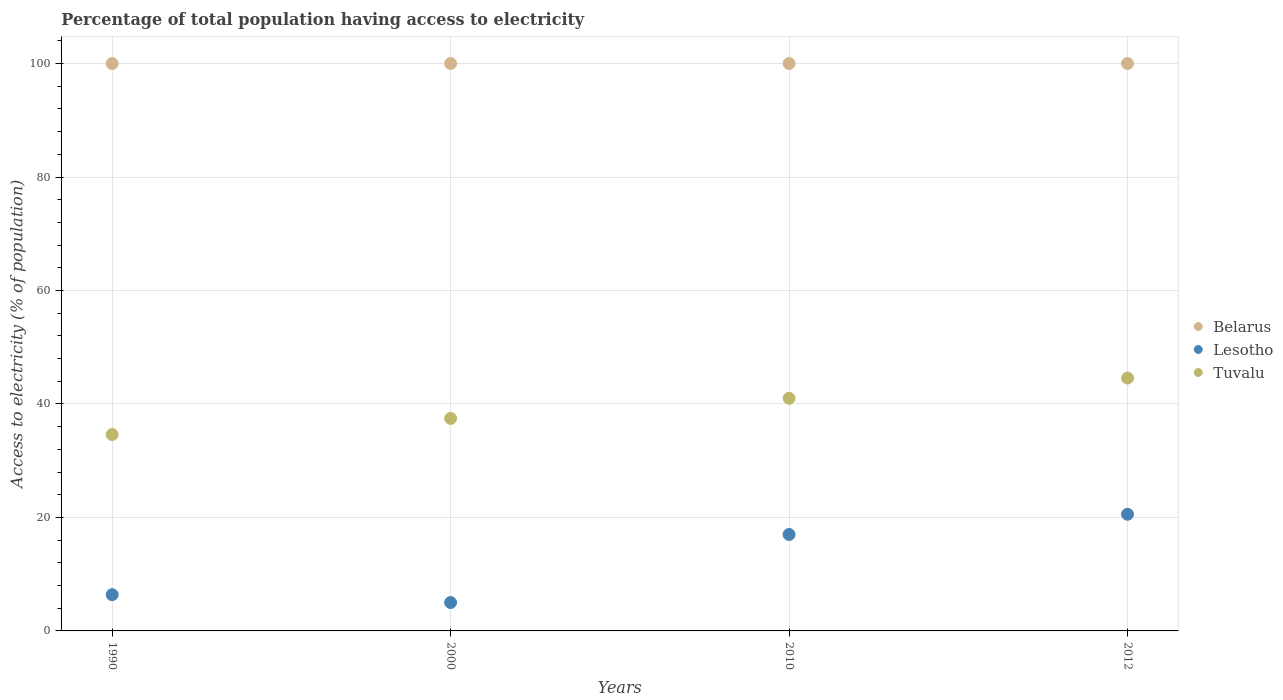What is the percentage of population that have access to electricity in Belarus in 2010?
Give a very brief answer. 100. Across all years, what is the maximum percentage of population that have access to electricity in Lesotho?
Provide a short and direct response. 20.56. Across all years, what is the minimum percentage of population that have access to electricity in Lesotho?
Provide a short and direct response. 5. In which year was the percentage of population that have access to electricity in Belarus minimum?
Provide a succinct answer. 1990. What is the total percentage of population that have access to electricity in Lesotho in the graph?
Your answer should be compact. 48.95. What is the difference between the percentage of population that have access to electricity in Lesotho in 1990 and that in 2010?
Provide a succinct answer. -10.61. What is the difference between the percentage of population that have access to electricity in Tuvalu in 1990 and the percentage of population that have access to electricity in Belarus in 2012?
Offer a very short reply. -65.38. What is the average percentage of population that have access to electricity in Tuvalu per year?
Keep it short and to the point. 39.41. In the year 2010, what is the difference between the percentage of population that have access to electricity in Lesotho and percentage of population that have access to electricity in Tuvalu?
Your response must be concise. -24. What is the ratio of the percentage of population that have access to electricity in Tuvalu in 2000 to that in 2012?
Your answer should be compact. 0.84. Is the difference between the percentage of population that have access to electricity in Lesotho in 1990 and 2012 greater than the difference between the percentage of population that have access to electricity in Tuvalu in 1990 and 2012?
Keep it short and to the point. No. What is the difference between the highest and the second highest percentage of population that have access to electricity in Lesotho?
Your answer should be compact. 3.56. What is the difference between the highest and the lowest percentage of population that have access to electricity in Tuvalu?
Make the answer very short. 9.95. Does the percentage of population that have access to electricity in Lesotho monotonically increase over the years?
Your answer should be very brief. No. Is the percentage of population that have access to electricity in Tuvalu strictly greater than the percentage of population that have access to electricity in Belarus over the years?
Ensure brevity in your answer.  No. Is the percentage of population that have access to electricity in Belarus strictly less than the percentage of population that have access to electricity in Tuvalu over the years?
Offer a terse response. No. How many dotlines are there?
Make the answer very short. 3. How many years are there in the graph?
Your answer should be very brief. 4. Are the values on the major ticks of Y-axis written in scientific E-notation?
Provide a short and direct response. No. Where does the legend appear in the graph?
Provide a short and direct response. Center right. How are the legend labels stacked?
Offer a terse response. Vertical. What is the title of the graph?
Provide a succinct answer. Percentage of total population having access to electricity. What is the label or title of the Y-axis?
Your answer should be very brief. Access to electricity (% of population). What is the Access to electricity (% of population) in Lesotho in 1990?
Ensure brevity in your answer.  6.39. What is the Access to electricity (% of population) of Tuvalu in 1990?
Offer a very short reply. 34.62. What is the Access to electricity (% of population) in Lesotho in 2000?
Give a very brief answer. 5. What is the Access to electricity (% of population) in Tuvalu in 2000?
Your answer should be compact. 37.46. What is the Access to electricity (% of population) of Belarus in 2010?
Ensure brevity in your answer.  100. What is the Access to electricity (% of population) of Lesotho in 2010?
Make the answer very short. 17. What is the Access to electricity (% of population) of Tuvalu in 2010?
Provide a short and direct response. 41. What is the Access to electricity (% of population) of Belarus in 2012?
Offer a terse response. 100. What is the Access to electricity (% of population) in Lesotho in 2012?
Give a very brief answer. 20.56. What is the Access to electricity (% of population) of Tuvalu in 2012?
Your response must be concise. 44.56. Across all years, what is the maximum Access to electricity (% of population) in Belarus?
Provide a short and direct response. 100. Across all years, what is the maximum Access to electricity (% of population) of Lesotho?
Ensure brevity in your answer.  20.56. Across all years, what is the maximum Access to electricity (% of population) of Tuvalu?
Your answer should be very brief. 44.56. Across all years, what is the minimum Access to electricity (% of population) in Belarus?
Provide a succinct answer. 100. Across all years, what is the minimum Access to electricity (% of population) of Lesotho?
Offer a terse response. 5. Across all years, what is the minimum Access to electricity (% of population) of Tuvalu?
Make the answer very short. 34.62. What is the total Access to electricity (% of population) in Belarus in the graph?
Your answer should be very brief. 400. What is the total Access to electricity (% of population) of Lesotho in the graph?
Offer a terse response. 48.95. What is the total Access to electricity (% of population) of Tuvalu in the graph?
Your answer should be compact. 157.63. What is the difference between the Access to electricity (% of population) of Belarus in 1990 and that in 2000?
Offer a terse response. 0. What is the difference between the Access to electricity (% of population) in Lesotho in 1990 and that in 2000?
Give a very brief answer. 1.39. What is the difference between the Access to electricity (% of population) of Tuvalu in 1990 and that in 2000?
Your answer should be compact. -2.84. What is the difference between the Access to electricity (% of population) in Lesotho in 1990 and that in 2010?
Provide a succinct answer. -10.61. What is the difference between the Access to electricity (% of population) in Tuvalu in 1990 and that in 2010?
Make the answer very short. -6.38. What is the difference between the Access to electricity (% of population) of Lesotho in 1990 and that in 2012?
Offer a very short reply. -14.17. What is the difference between the Access to electricity (% of population) of Tuvalu in 1990 and that in 2012?
Offer a terse response. -9.95. What is the difference between the Access to electricity (% of population) in Lesotho in 2000 and that in 2010?
Your answer should be compact. -12. What is the difference between the Access to electricity (% of population) in Tuvalu in 2000 and that in 2010?
Your answer should be compact. -3.54. What is the difference between the Access to electricity (% of population) in Lesotho in 2000 and that in 2012?
Offer a very short reply. -15.56. What is the difference between the Access to electricity (% of population) of Tuvalu in 2000 and that in 2012?
Give a very brief answer. -7.11. What is the difference between the Access to electricity (% of population) in Lesotho in 2010 and that in 2012?
Your answer should be very brief. -3.56. What is the difference between the Access to electricity (% of population) in Tuvalu in 2010 and that in 2012?
Provide a short and direct response. -3.56. What is the difference between the Access to electricity (% of population) in Belarus in 1990 and the Access to electricity (% of population) in Lesotho in 2000?
Your answer should be very brief. 95. What is the difference between the Access to electricity (% of population) in Belarus in 1990 and the Access to electricity (% of population) in Tuvalu in 2000?
Make the answer very short. 62.54. What is the difference between the Access to electricity (% of population) in Lesotho in 1990 and the Access to electricity (% of population) in Tuvalu in 2000?
Keep it short and to the point. -31.07. What is the difference between the Access to electricity (% of population) in Lesotho in 1990 and the Access to electricity (% of population) in Tuvalu in 2010?
Provide a succinct answer. -34.61. What is the difference between the Access to electricity (% of population) of Belarus in 1990 and the Access to electricity (% of population) of Lesotho in 2012?
Your answer should be compact. 79.44. What is the difference between the Access to electricity (% of population) of Belarus in 1990 and the Access to electricity (% of population) of Tuvalu in 2012?
Your answer should be very brief. 55.44. What is the difference between the Access to electricity (% of population) of Lesotho in 1990 and the Access to electricity (% of population) of Tuvalu in 2012?
Ensure brevity in your answer.  -38.17. What is the difference between the Access to electricity (% of population) in Belarus in 2000 and the Access to electricity (% of population) in Tuvalu in 2010?
Provide a short and direct response. 59. What is the difference between the Access to electricity (% of population) of Lesotho in 2000 and the Access to electricity (% of population) of Tuvalu in 2010?
Your response must be concise. -36. What is the difference between the Access to electricity (% of population) in Belarus in 2000 and the Access to electricity (% of population) in Lesotho in 2012?
Give a very brief answer. 79.44. What is the difference between the Access to electricity (% of population) of Belarus in 2000 and the Access to electricity (% of population) of Tuvalu in 2012?
Provide a succinct answer. 55.44. What is the difference between the Access to electricity (% of population) in Lesotho in 2000 and the Access to electricity (% of population) in Tuvalu in 2012?
Your answer should be very brief. -39.56. What is the difference between the Access to electricity (% of population) in Belarus in 2010 and the Access to electricity (% of population) in Lesotho in 2012?
Give a very brief answer. 79.44. What is the difference between the Access to electricity (% of population) in Belarus in 2010 and the Access to electricity (% of population) in Tuvalu in 2012?
Offer a terse response. 55.44. What is the difference between the Access to electricity (% of population) of Lesotho in 2010 and the Access to electricity (% of population) of Tuvalu in 2012?
Your response must be concise. -27.56. What is the average Access to electricity (% of population) of Belarus per year?
Provide a short and direct response. 100. What is the average Access to electricity (% of population) of Lesotho per year?
Ensure brevity in your answer.  12.24. What is the average Access to electricity (% of population) in Tuvalu per year?
Provide a succinct answer. 39.41. In the year 1990, what is the difference between the Access to electricity (% of population) in Belarus and Access to electricity (% of population) in Lesotho?
Give a very brief answer. 93.61. In the year 1990, what is the difference between the Access to electricity (% of population) in Belarus and Access to electricity (% of population) in Tuvalu?
Give a very brief answer. 65.38. In the year 1990, what is the difference between the Access to electricity (% of population) in Lesotho and Access to electricity (% of population) in Tuvalu?
Your response must be concise. -28.23. In the year 2000, what is the difference between the Access to electricity (% of population) in Belarus and Access to electricity (% of population) in Tuvalu?
Your response must be concise. 62.54. In the year 2000, what is the difference between the Access to electricity (% of population) in Lesotho and Access to electricity (% of population) in Tuvalu?
Provide a short and direct response. -32.46. In the year 2010, what is the difference between the Access to electricity (% of population) in Lesotho and Access to electricity (% of population) in Tuvalu?
Make the answer very short. -24. In the year 2012, what is the difference between the Access to electricity (% of population) of Belarus and Access to electricity (% of population) of Lesotho?
Keep it short and to the point. 79.44. In the year 2012, what is the difference between the Access to electricity (% of population) of Belarus and Access to electricity (% of population) of Tuvalu?
Give a very brief answer. 55.44. What is the ratio of the Access to electricity (% of population) of Belarus in 1990 to that in 2000?
Your response must be concise. 1. What is the ratio of the Access to electricity (% of population) of Lesotho in 1990 to that in 2000?
Your answer should be compact. 1.28. What is the ratio of the Access to electricity (% of population) in Tuvalu in 1990 to that in 2000?
Keep it short and to the point. 0.92. What is the ratio of the Access to electricity (% of population) in Belarus in 1990 to that in 2010?
Make the answer very short. 1. What is the ratio of the Access to electricity (% of population) of Lesotho in 1990 to that in 2010?
Make the answer very short. 0.38. What is the ratio of the Access to electricity (% of population) in Tuvalu in 1990 to that in 2010?
Offer a very short reply. 0.84. What is the ratio of the Access to electricity (% of population) of Belarus in 1990 to that in 2012?
Keep it short and to the point. 1. What is the ratio of the Access to electricity (% of population) of Lesotho in 1990 to that in 2012?
Make the answer very short. 0.31. What is the ratio of the Access to electricity (% of population) of Tuvalu in 1990 to that in 2012?
Ensure brevity in your answer.  0.78. What is the ratio of the Access to electricity (% of population) in Lesotho in 2000 to that in 2010?
Provide a short and direct response. 0.29. What is the ratio of the Access to electricity (% of population) in Tuvalu in 2000 to that in 2010?
Offer a terse response. 0.91. What is the ratio of the Access to electricity (% of population) of Lesotho in 2000 to that in 2012?
Keep it short and to the point. 0.24. What is the ratio of the Access to electricity (% of population) of Tuvalu in 2000 to that in 2012?
Offer a very short reply. 0.84. What is the ratio of the Access to electricity (% of population) of Belarus in 2010 to that in 2012?
Give a very brief answer. 1. What is the ratio of the Access to electricity (% of population) of Lesotho in 2010 to that in 2012?
Give a very brief answer. 0.83. What is the ratio of the Access to electricity (% of population) in Tuvalu in 2010 to that in 2012?
Make the answer very short. 0.92. What is the difference between the highest and the second highest Access to electricity (% of population) of Lesotho?
Keep it short and to the point. 3.56. What is the difference between the highest and the second highest Access to electricity (% of population) in Tuvalu?
Provide a short and direct response. 3.56. What is the difference between the highest and the lowest Access to electricity (% of population) in Lesotho?
Your answer should be compact. 15.56. What is the difference between the highest and the lowest Access to electricity (% of population) in Tuvalu?
Offer a terse response. 9.95. 